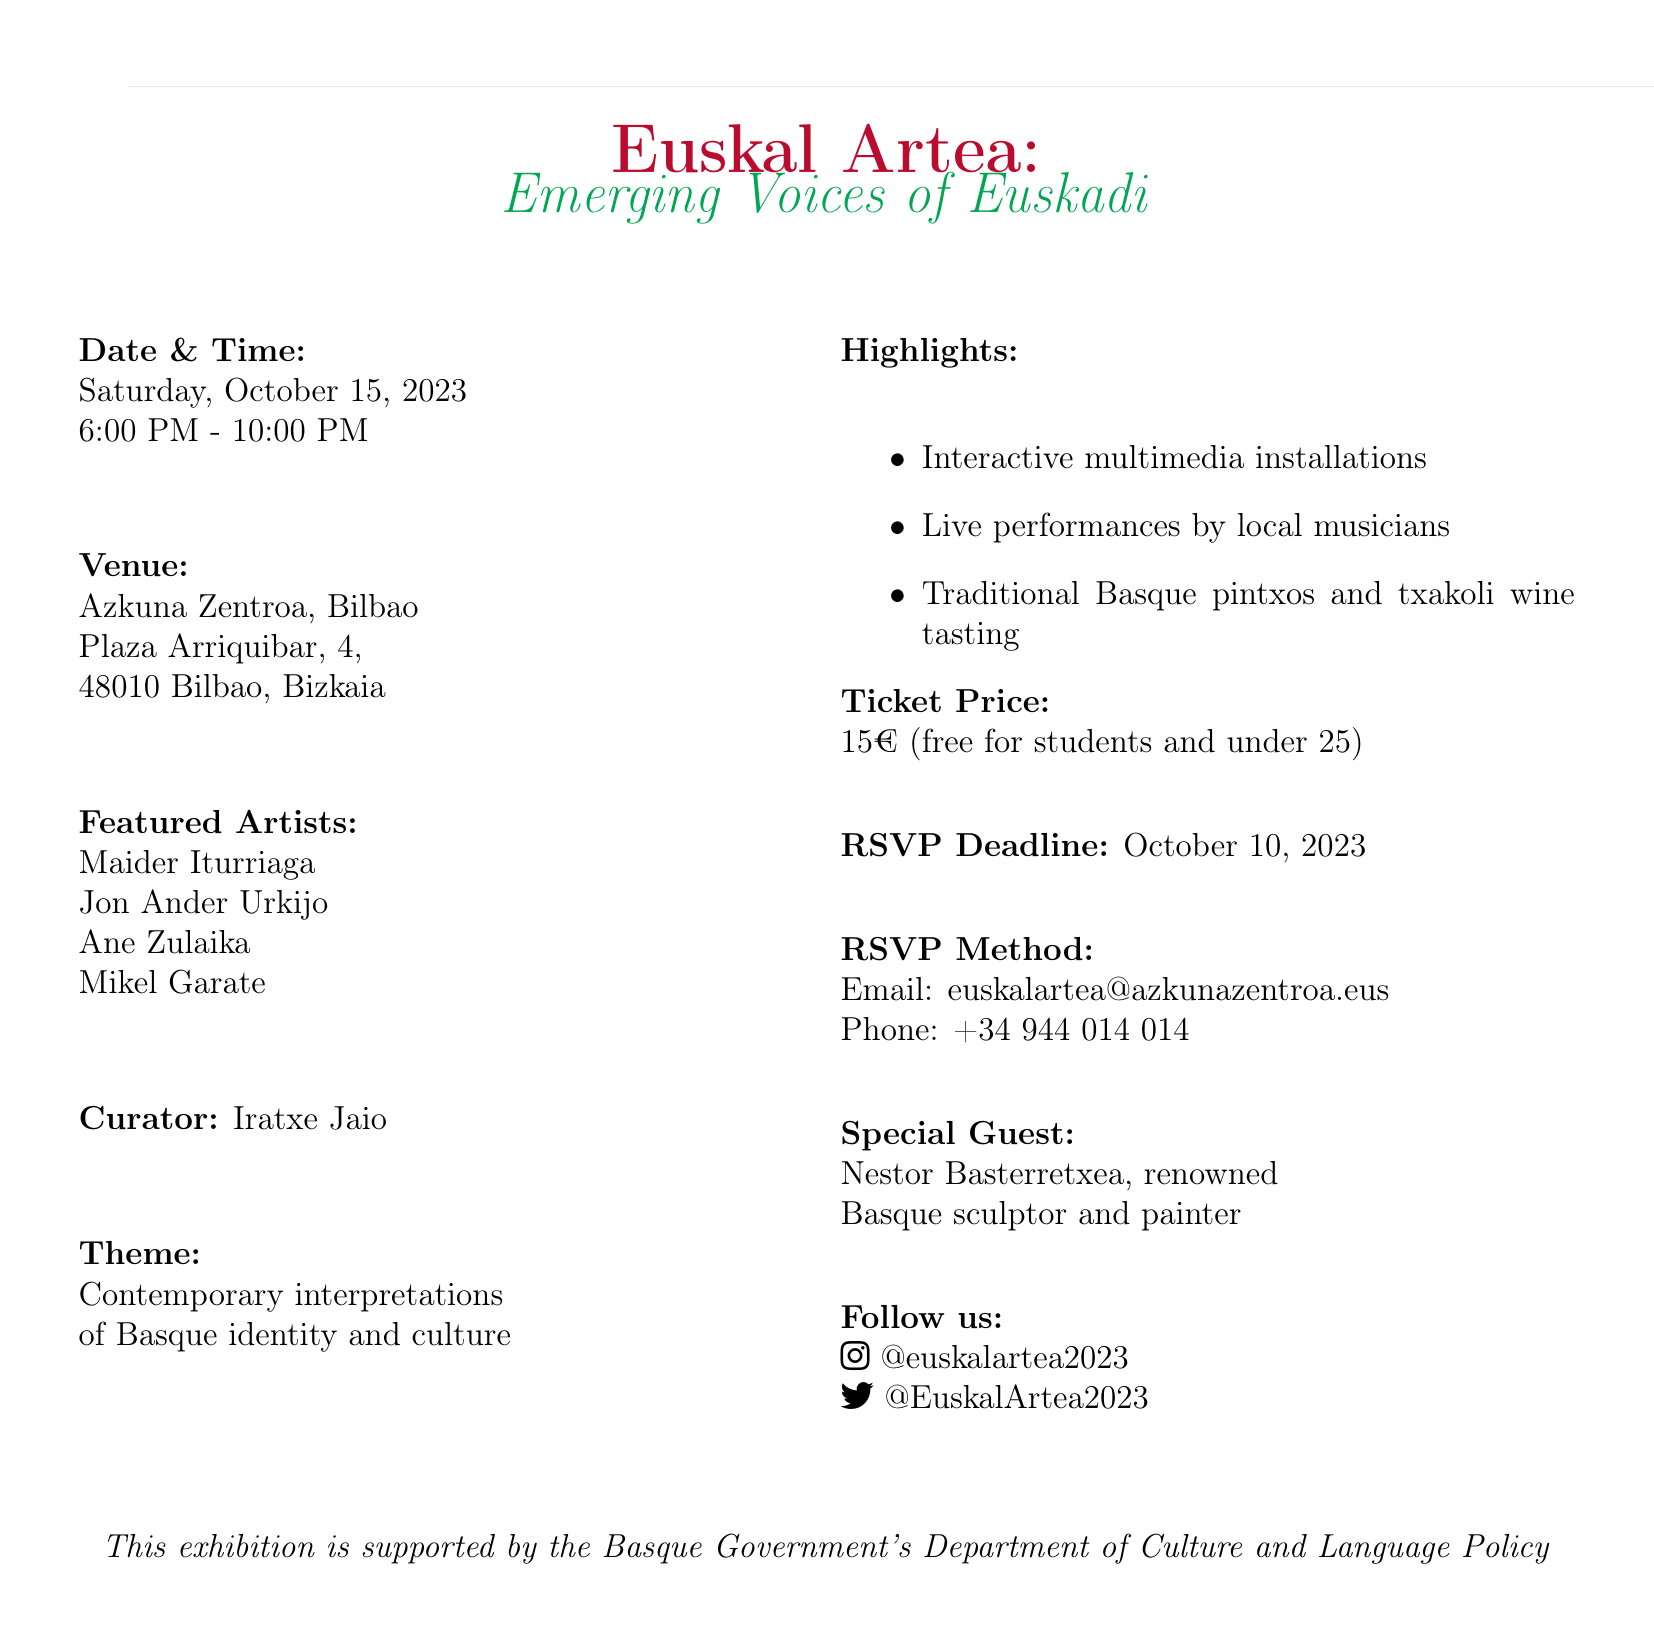What is the name of the exhibition? The exhibition is titled "Euskal Artea: Emerging Voices of Euskadi."
Answer: Euskal Artea: Emerging Voices of Euskadi Who is the curator of the exhibition? The document states that Iratxe Jaio is the curator.
Answer: Iratxe Jaio When is the RSVP deadline? The RSVP deadline mentioned in the document is October 10, 2023.
Answer: October 10, 2023 What is the ticket price for the exhibition? The ticket price for the exhibition is listed as 15€.
Answer: 15€ Which venue is hosting the event? The venue for the event is Azkuna Zentroa, Bilbao.
Answer: Azkuna Zentroa, Bilbao What theme does the exhibition focus on? The theme of the exhibition relates to contemporary interpretations of Basque identity and culture.
Answer: Contemporary interpretations of Basque identity and culture How many featured artists are mentioned? There are four featured artists listed in the document.
Answer: Four What special guest will be present at the exhibition? The document mentions Nestor Basterretxea as a special guest.
Answer: Nestor Basterretxea What type of food will be available at the event? The highlights indicate that traditional Basque pintxos and txakoli wine tasting will be available.
Answer: Traditional Basque pintxos and txakoli wine tasting 